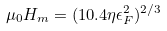Convert formula to latex. <formula><loc_0><loc_0><loc_500><loc_500>\mu _ { 0 } H _ { m } = ( 1 0 . 4 \eta \epsilon ^ { 2 } _ { F } ) ^ { 2 / 3 } \\</formula> 